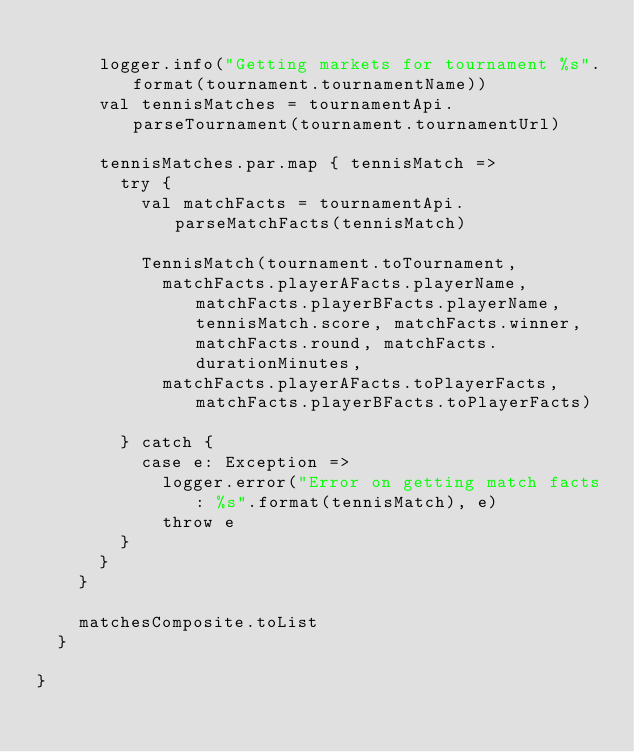Convert code to text. <code><loc_0><loc_0><loc_500><loc_500><_Scala_>
      logger.info("Getting markets for tournament %s".format(tournament.tournamentName))
      val tennisMatches = tournamentApi.parseTournament(tournament.tournamentUrl)

      tennisMatches.par.map { tennisMatch =>
        try {
          val matchFacts = tournamentApi.parseMatchFacts(tennisMatch)

          TennisMatch(tournament.toTournament,
            matchFacts.playerAFacts.playerName, matchFacts.playerBFacts.playerName, tennisMatch.score, matchFacts.winner, matchFacts.round, matchFacts.durationMinutes,
            matchFacts.playerAFacts.toPlayerFacts, matchFacts.playerBFacts.toPlayerFacts)

        } catch {
          case e: Exception =>
            logger.error("Error on getting match facts: %s".format(tennisMatch), e)
            throw e
        }
      }
    }

    matchesComposite.toList
  }

}</code> 